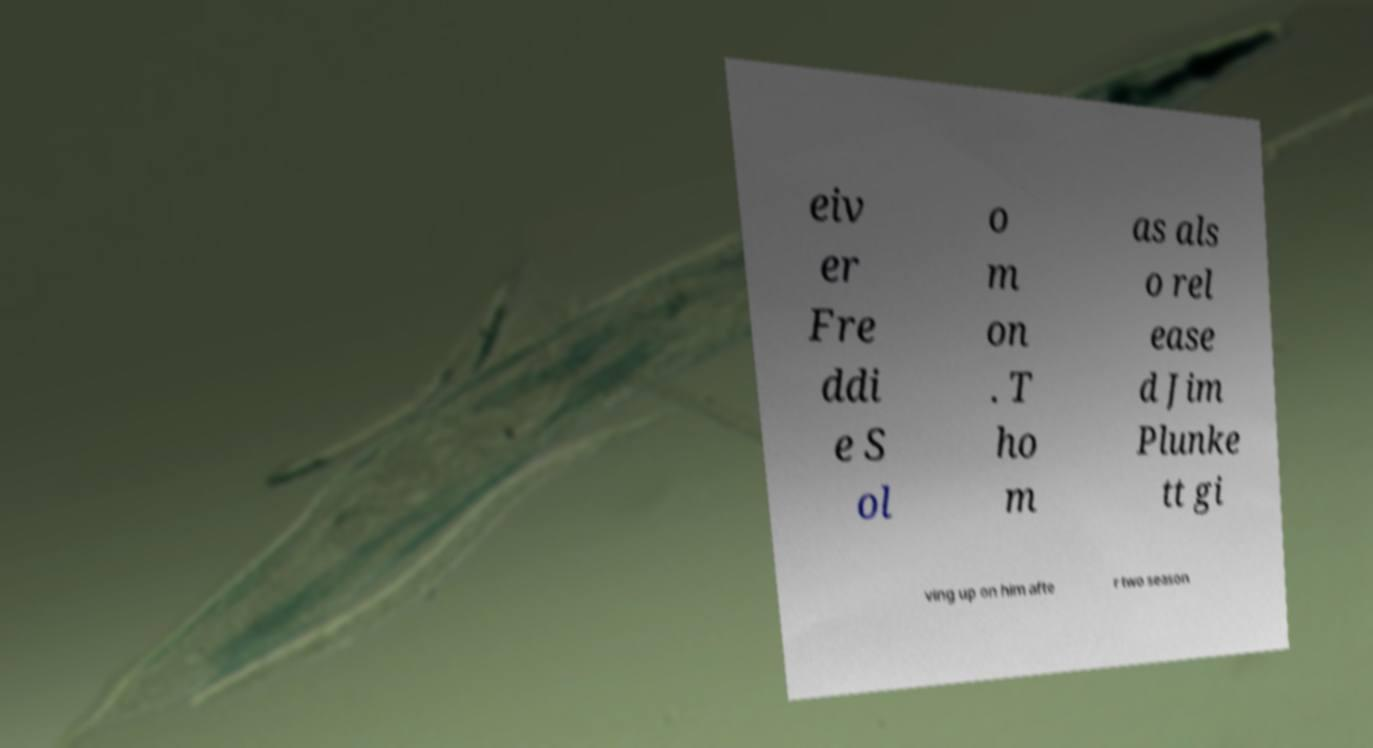Can you accurately transcribe the text from the provided image for me? eiv er Fre ddi e S ol o m on . T ho m as als o rel ease d Jim Plunke tt gi ving up on him afte r two season 